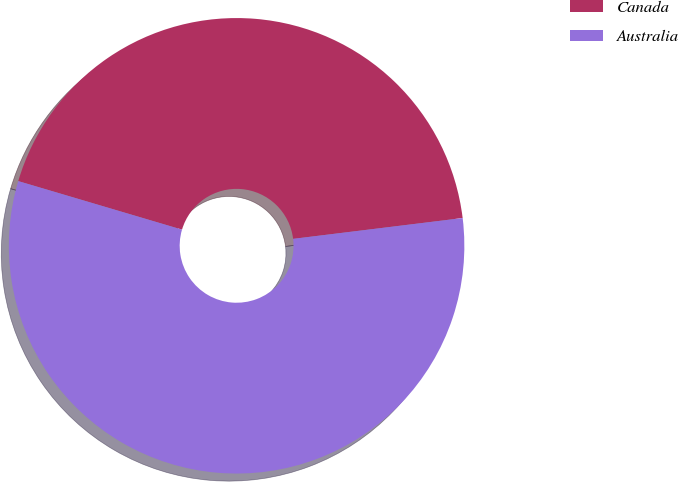Convert chart to OTSL. <chart><loc_0><loc_0><loc_500><loc_500><pie_chart><fcel>Canada<fcel>Australia<nl><fcel>43.47%<fcel>56.53%<nl></chart> 